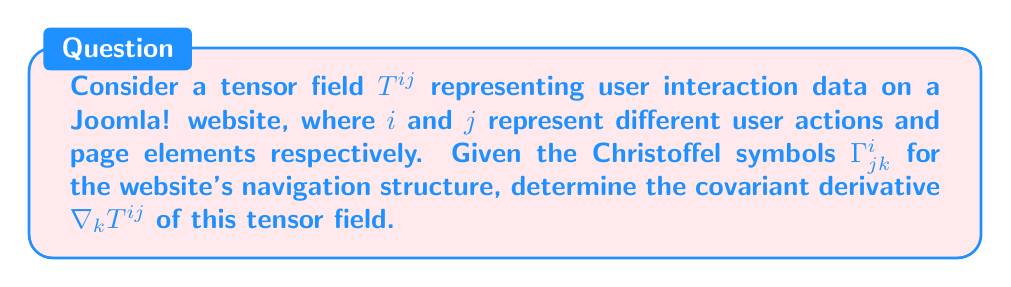Solve this math problem. To find the covariant derivative of the tensor field $T^{ij}$, we follow these steps:

1. Recall the formula for the covariant derivative of a contravariant tensor:

   $$\nabla_k T^{ij} = \partial_k T^{ij} + \Gamma^i_{mk}T^{mj} + \Gamma^j_{mk}T^{im}$$

2. Break down the components:
   - $\partial_k T^{ij}$ is the partial derivative of $T^{ij}$ with respect to $k$
   - $\Gamma^i_{mk}T^{mj}$ accounts for the change in the $i$ component
   - $\Gamma^j_{mk}T^{im}$ accounts for the change in the $j$ component

3. In the context of Joomla! CMS:
   - $T^{ij}$ represents user interaction data
   - $i$ could represent different user actions (e.g., click, scroll, form submit)
   - $j$ could represent different page elements (e.g., menu, article, module)
   - $k$ could represent the navigation path or user session progress

4. The Christoffel symbols $\Gamma^i_{jk}$ represent how the website's structure affects user interactions as they navigate through the site.

5. To calculate $\nabla_k T^{ij}$:
   a) Compute $\partial_k T^{ij}$ by differentiating the user interaction data with respect to the navigation path.
   b) Calculate $\Gamma^i_{mk}T^{mj}$ by summing over $m$ for all possible user actions.
   c) Calculate $\Gamma^j_{mk}T^{im}$ by summing over $m$ for all possible page elements.
   d) Sum all these terms to get the final result.

The covariant derivative $\nabla_k T^{ij}$ gives us information about how user interactions change as they navigate through the Joomla! website, taking into account the site's structure and layout.
Answer: $$\nabla_k T^{ij} = \partial_k T^{ij} + \Gamma^i_{mk}T^{mj} + \Gamma^j_{mk}T^{im}$$ 